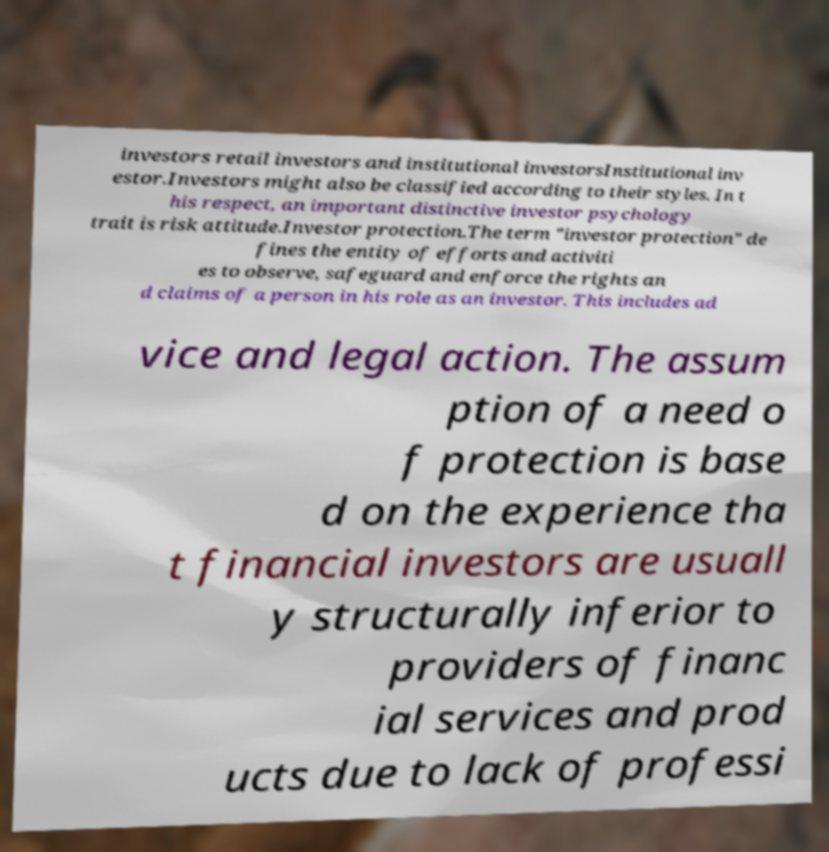Can you read and provide the text displayed in the image?This photo seems to have some interesting text. Can you extract and type it out for me? investors retail investors and institutional investorsInstitutional inv estor.Investors might also be classified according to their styles. In t his respect, an important distinctive investor psychology trait is risk attitude.Investor protection.The term "investor protection" de fines the entity of efforts and activiti es to observe, safeguard and enforce the rights an d claims of a person in his role as an investor. This includes ad vice and legal action. The assum ption of a need o f protection is base d on the experience tha t financial investors are usuall y structurally inferior to providers of financ ial services and prod ucts due to lack of professi 